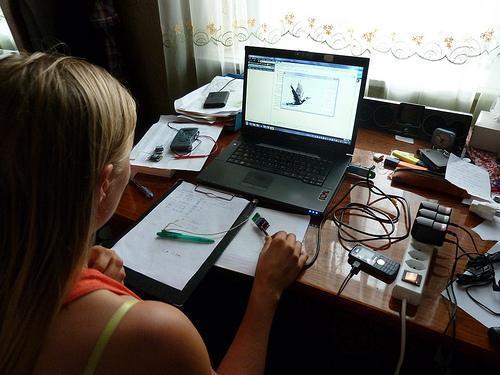How many people are in the picture?
Give a very brief answer. 1. How many pads of paper are located in front of the laptop?
Give a very brief answer. 2. 